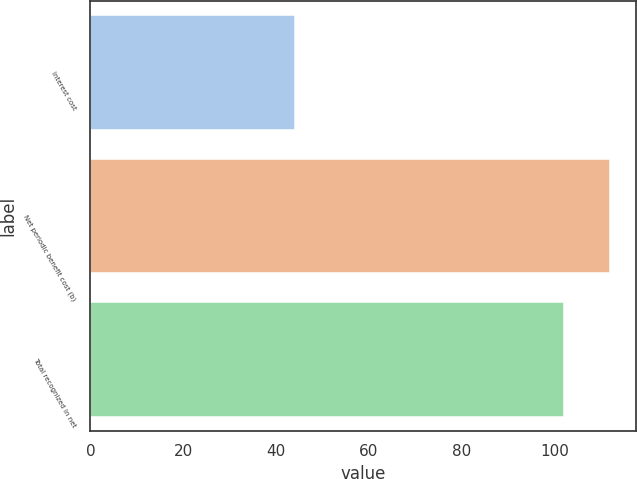Convert chart. <chart><loc_0><loc_0><loc_500><loc_500><bar_chart><fcel>Interest cost<fcel>Net periodic benefit cost (b)<fcel>Total recognized in net<nl><fcel>44<fcel>112<fcel>102<nl></chart> 